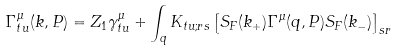<formula> <loc_0><loc_0><loc_500><loc_500>& \Gamma ^ { \mu } _ { t u } ( k , P ) = Z _ { 1 } \gamma ^ { \mu } _ { t u } + \int _ { q } K _ { t u ; r s } \left [ S _ { F } ( k _ { + } ) \Gamma ^ { \mu } ( q , P ) S _ { F } ( k _ { - } ) \right ] _ { s r }</formula> 